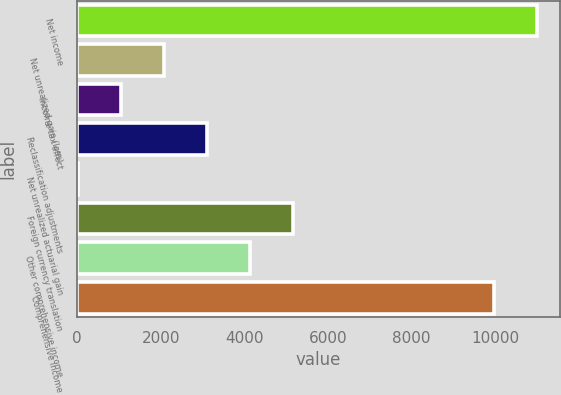Convert chart to OTSL. <chart><loc_0><loc_0><loc_500><loc_500><bar_chart><fcel>Net income<fcel>Net unrealized gain (loss)<fcel>Income tax effect<fcel>Reclassification adjustments<fcel>Net unrealized actuarial gain<fcel>Foreign currency translation<fcel>Other comprehensive income<fcel>Comprehensive income<nl><fcel>10998.5<fcel>2073<fcel>1044.5<fcel>3101.5<fcel>16<fcel>5158.5<fcel>4130<fcel>9970<nl></chart> 